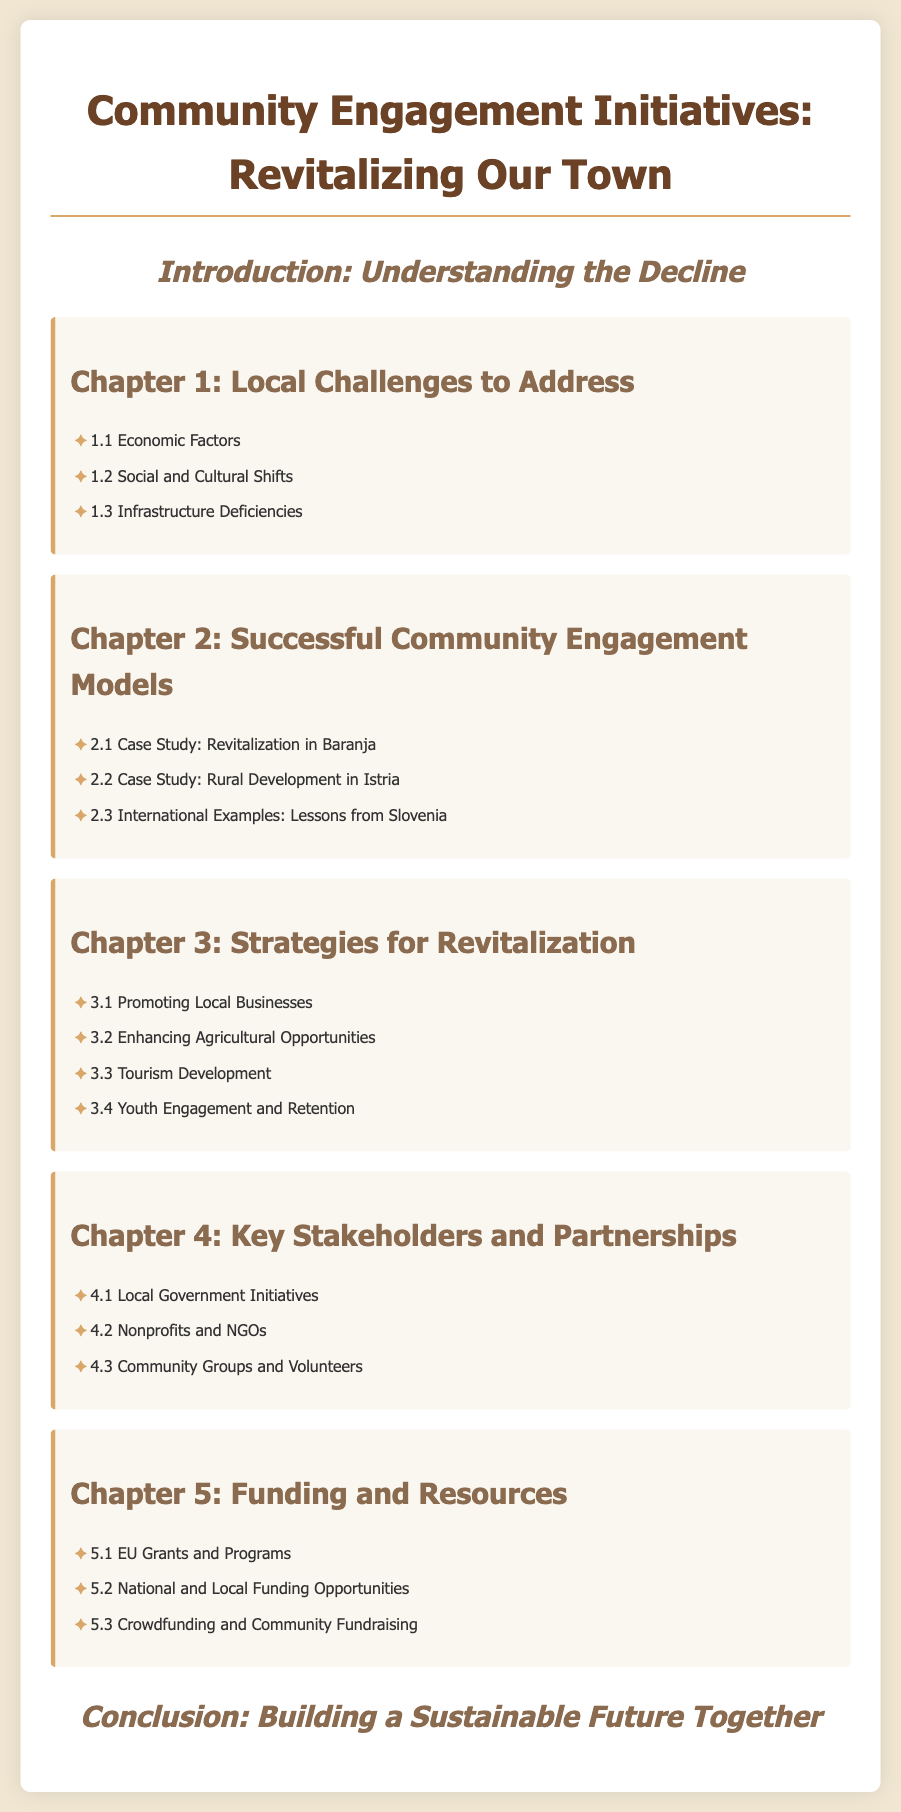What is the title of the document? The title is the main heading of the document and is usually prominently displayed at the top.
Answer: Community Engagement Initiatives: Revitalizing Our Town What is the first chapter about? The first chapter is identified by its heading and covers specific local issues that need to be addressed as part of the community revitalization effort.
Answer: Local Challenges to Address How many case studies are presented in Chapter 2? Chapter 2 lists several case studies, and the number can be quickly counted from the bullet points under this chapter.
Answer: 3 What is one strategy mentioned for revitalization in Chapter 3? Chapter 3 provides various strategies for revitalization which include specific actions to support community growth.
Answer: Promoting Local Businesses Who are potential key stakeholders identified in Chapter 4? Chapter 4 lists various parties involved in community engagement, highlighting their roles and significance.
Answer: Local Government Initiatives What type of funding opportunities are discussed in Chapter 5? Chapter 5 outlines different avenues for financial support aimed at assisting community projects and initiatives.
Answer: EU Grants and Programs What is the focus of the conclusion? The conclusion typically summarizes the overall message or intent of the document and highlights future aspirations.
Answer: Building a Sustainable Future Together What showcase is used to present information in the document? The document follows a structured format that includes chapters and subtopics, displaying information clearly through headings and lists.
Answer: Table of contents How many chapters are there in the document? The total number of chapters can be determined by counting the main headings included in the document.
Answer: 5 